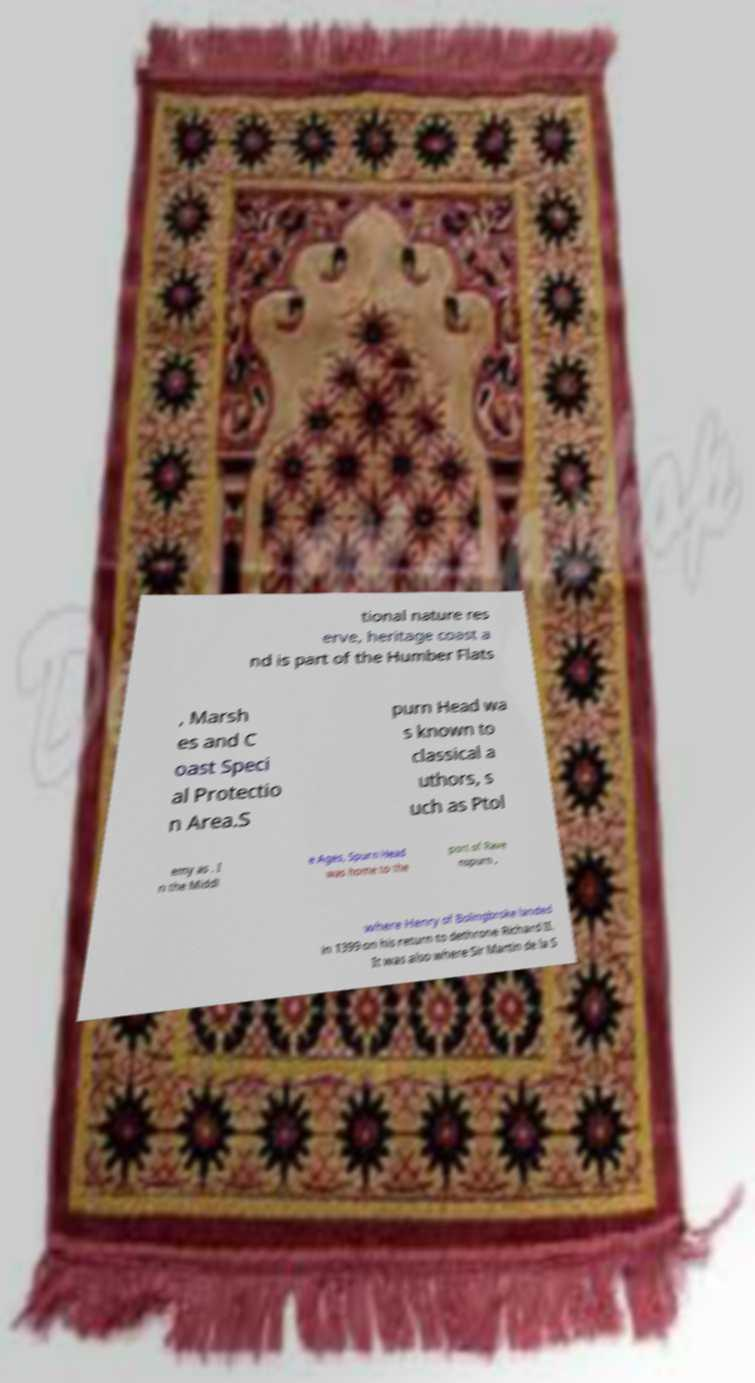Can you accurately transcribe the text from the provided image for me? tional nature res erve, heritage coast a nd is part of the Humber Flats , Marsh es and C oast Speci al Protectio n Area.S purn Head wa s known to classical a uthors, s uch as Ptol emy as . I n the Middl e Ages, Spurn Head was home to the port of Rave nspurn , where Henry of Bolingbroke landed in 1399 on his return to dethrone Richard II. It was also where Sir Martin de la S 